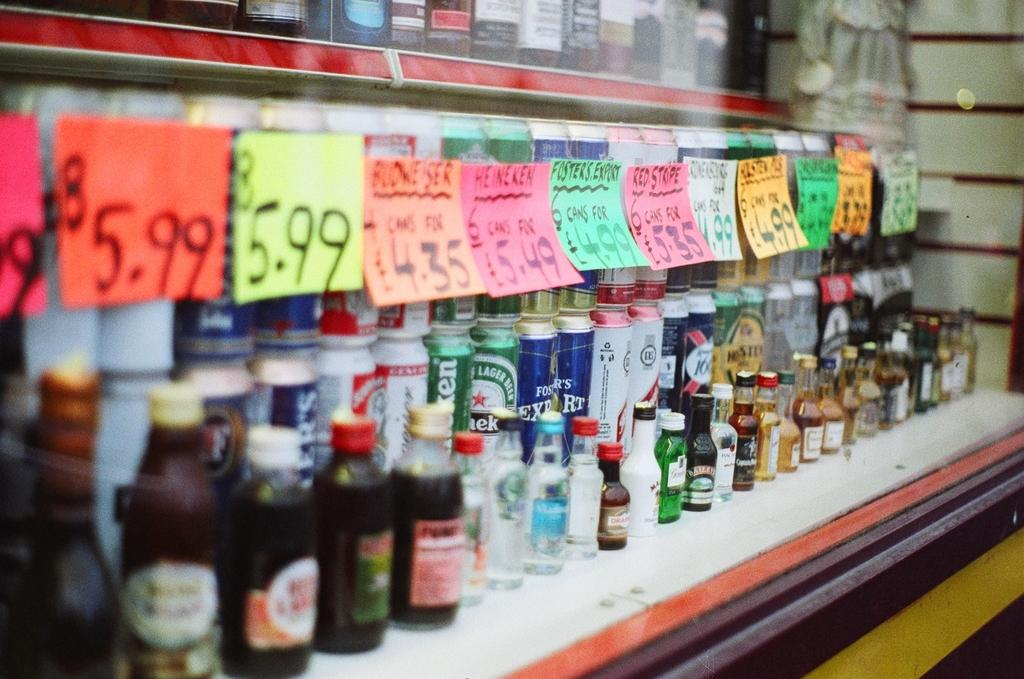<image>
Render a clear and concise summary of the photo. Some cans and bottles on a shelf, including Foster's export. 